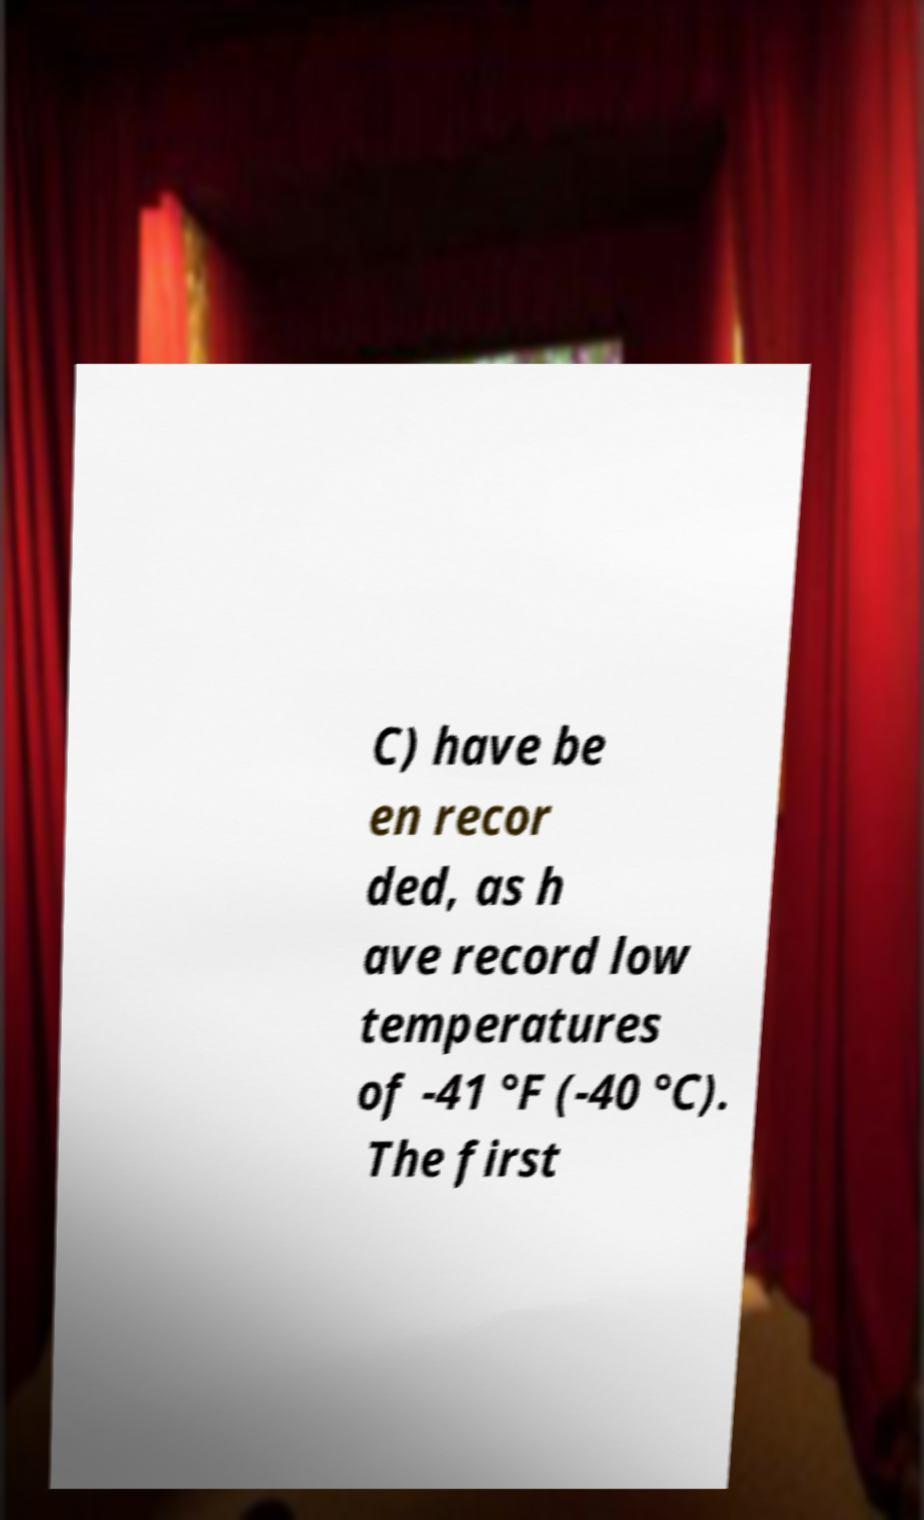There's text embedded in this image that I need extracted. Can you transcribe it verbatim? C) have be en recor ded, as h ave record low temperatures of -41 °F (-40 °C). The first 